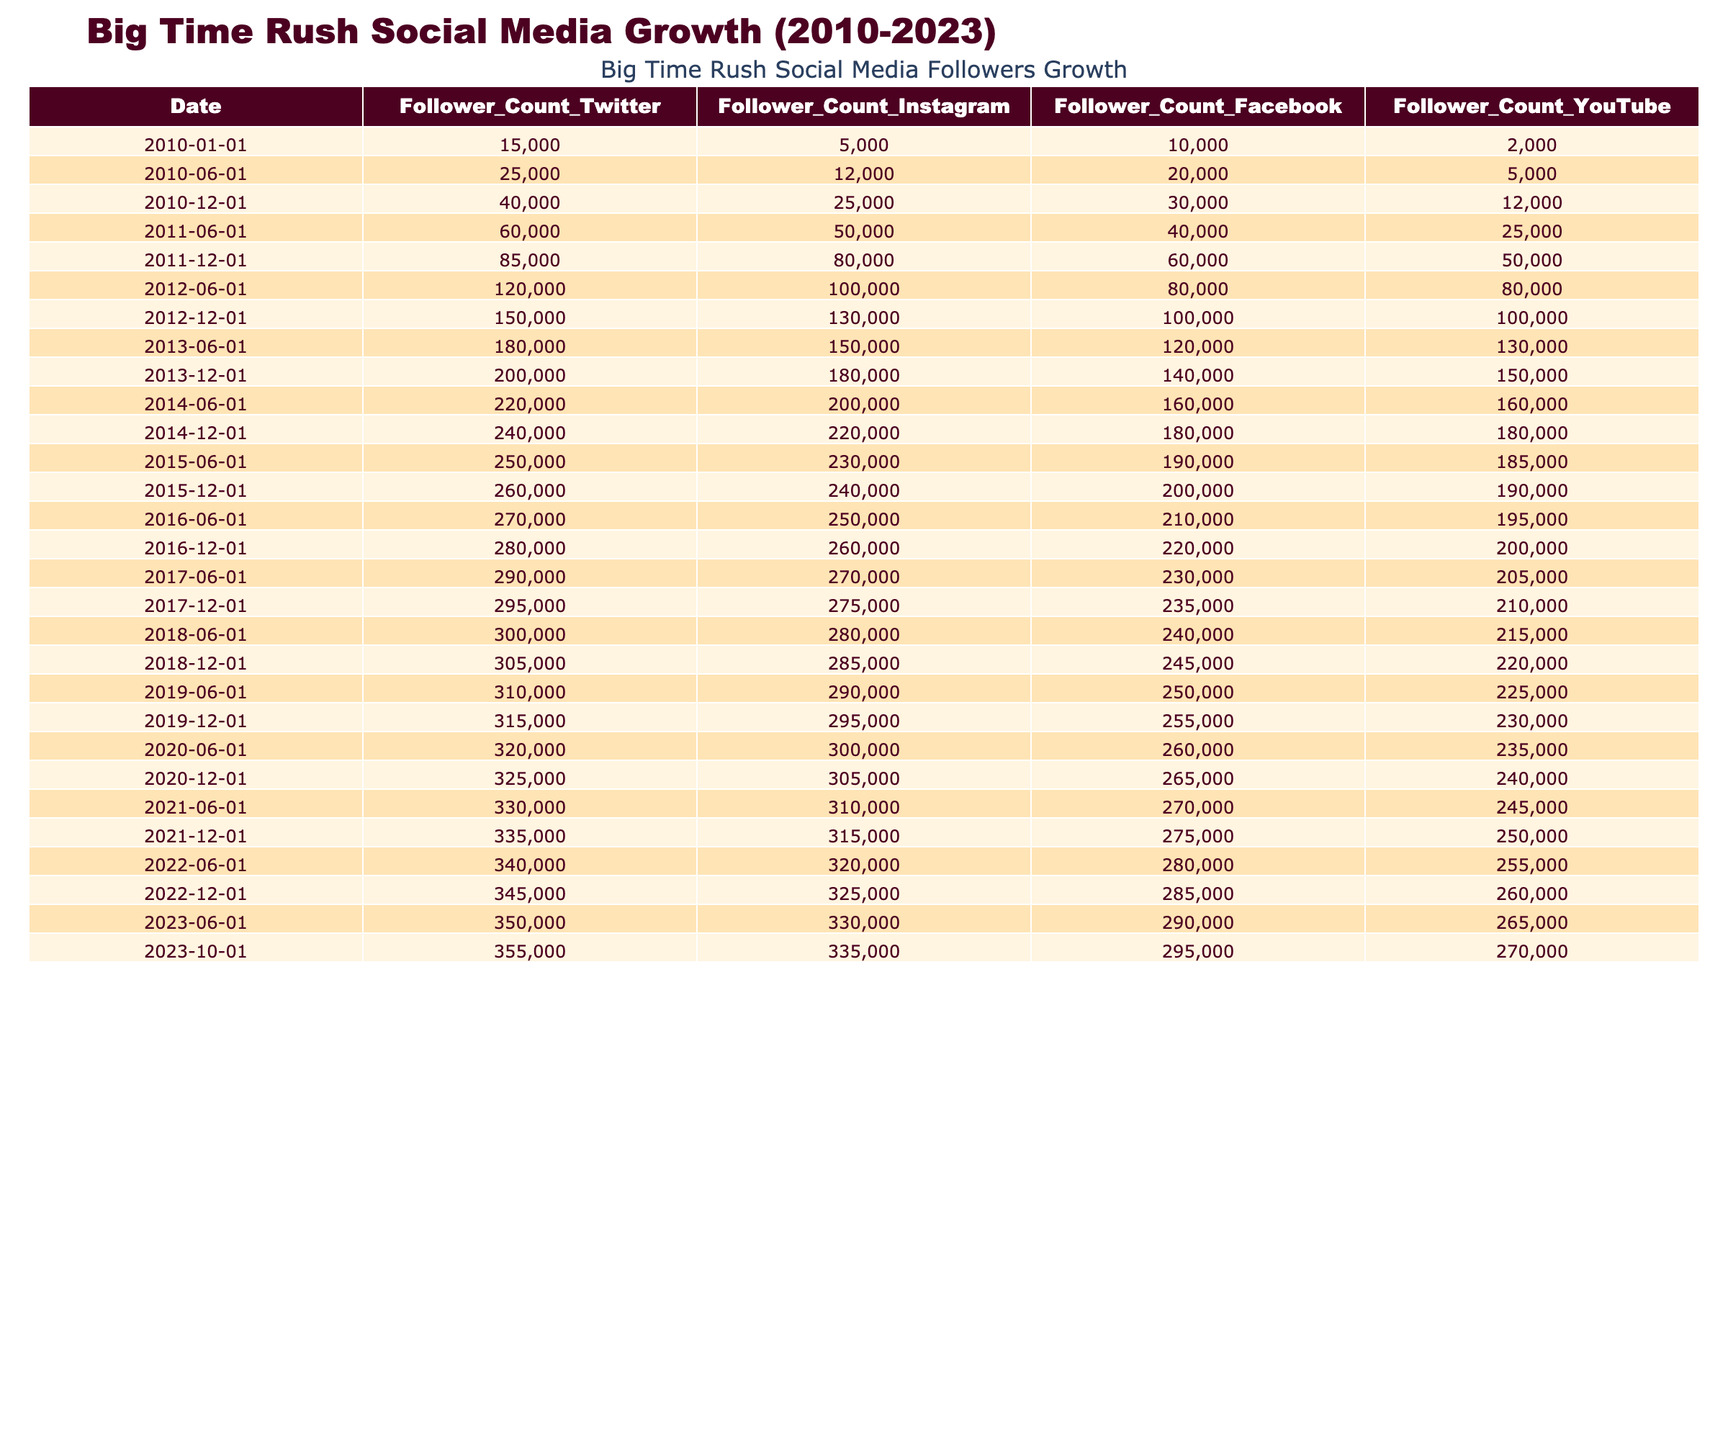What was the follower count for Instagram on December 1, 2012? The table shows the follower count for Instagram on December 1, 2012, as 130,000.
Answer: 130,000 Which platform had the highest follower count by June 1, 2015? By June 1, 2015, Facebook had the highest follower count at 190,000, compared to other platforms listed.
Answer: Facebook: 190,000 What is the total follower count for all platforms on June 1, 2014? Summing the follower counts for June 1, 2014, gives: Twitter (220,000) + Instagram (200,000) + Facebook (160,000) + YouTube (160,000) = 740,000.
Answer: 740,000 Did the follower count for YouTube increase every year from 2010 to 2023? The table shows that the YouTube follower count did increase every measurement date, confirming a consistent growth trend.
Answer: Yes What was the average follower count for Twitter from 2010 to 2013? The Twitter follower counts for the specified period are: 15,000, 25,000, 40,000, 60,000, 85,000, 120,000, 150,000, 180,000, and 200,000. Summing these gives 1,000,000; dividing by 9 gives an average of approximately 111,111.
Answer: 111,111 What was the percentage increase in Facebook followers from June 1, 2010, to June 1, 2012? The Facebook follower count on June 1, 2010, was 20,000 and on June 1, 2012, it was 80,000. The increase is 80,000 - 20,000 = 60,000; the percentage increase is (60,000 / 20,000) * 100 = 300%.
Answer: 300% What was the maximum follower count for Instagram, and when was it reached? The maximum follower count for Instagram was 335,000, which was reached on October 1, 2023, as shown in the data.
Answer: 335,000 on October 1, 2023 Which platform had the lowest follower count in June 2011? The table indicates that YouTube had the lowest follower count in June 2011 at 25,000, compared to other platforms.
Answer: YouTube: 25,000 How much did the Twitter follower count grow from December 1, 2015, to June 1, 2017? On December 1, 2015, the Twitter follower count was 260,000, and by June 1, 2017, it had increased to 290,000. The growth is 290,000 - 260,000 = 30,000.
Answer: 30,000 Was there ever a date when the follower counts for all platforms were equal? No, by reviewing the table, the counts for each platform do not match on any date, showing consistent differences between follower counts.
Answer: No 